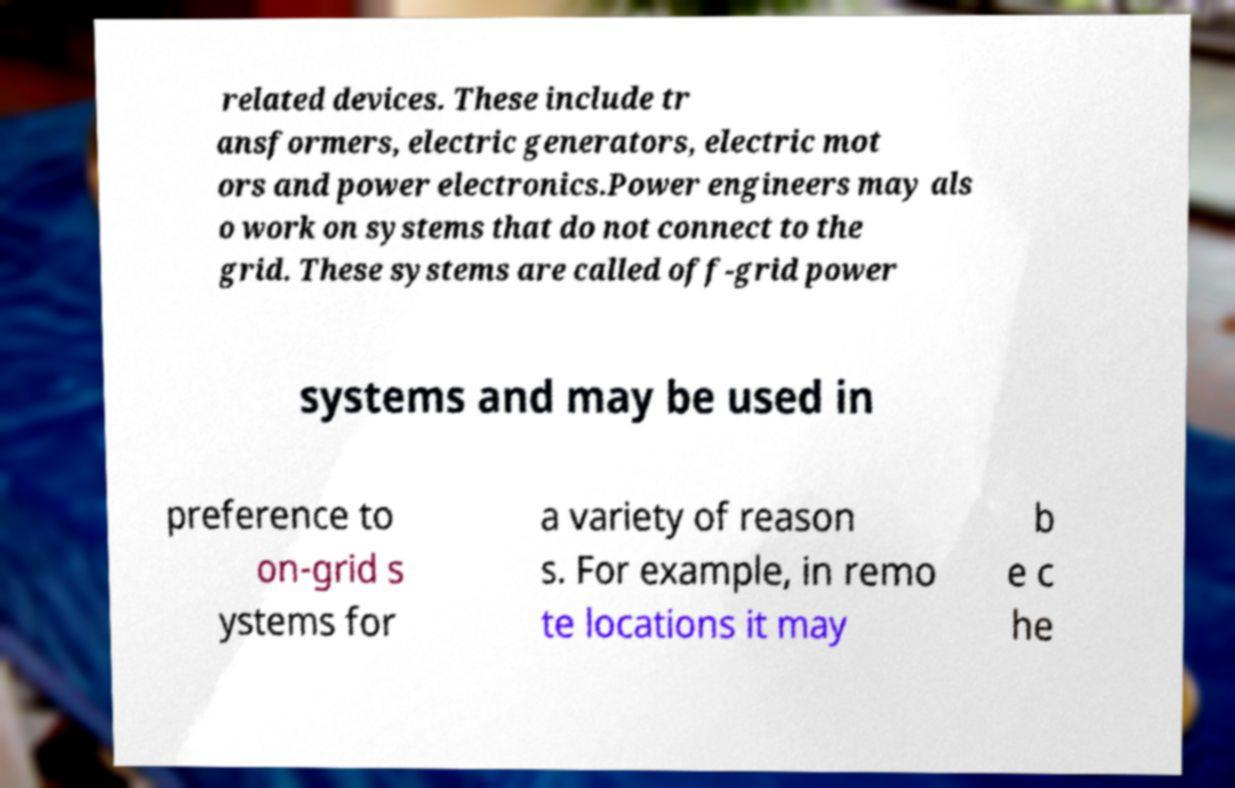For documentation purposes, I need the text within this image transcribed. Could you provide that? related devices. These include tr ansformers, electric generators, electric mot ors and power electronics.Power engineers may als o work on systems that do not connect to the grid. These systems are called off-grid power systems and may be used in preference to on-grid s ystems for a variety of reason s. For example, in remo te locations it may b e c he 